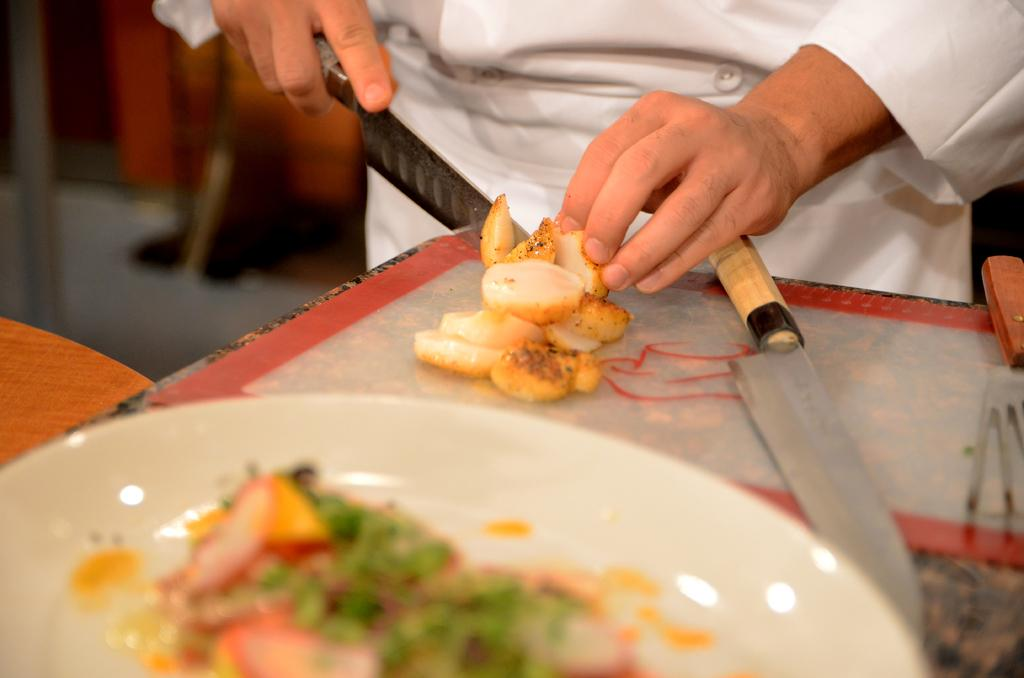What is the main subject of the image? There is a person standing in the image. What is the person holding in the image? The person is holding a knife. What else can be seen in the image besides the person? There is food on a plate in the image. What type of umbrella is the person using to prepare the food in the image? There is no umbrella present in the image, and the person is not using any tool to prepare the food. 